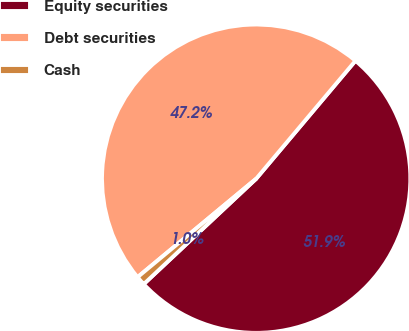Convert chart. <chart><loc_0><loc_0><loc_500><loc_500><pie_chart><fcel>Equity securities<fcel>Debt securities<fcel>Cash<nl><fcel>51.88%<fcel>47.16%<fcel>0.96%<nl></chart> 